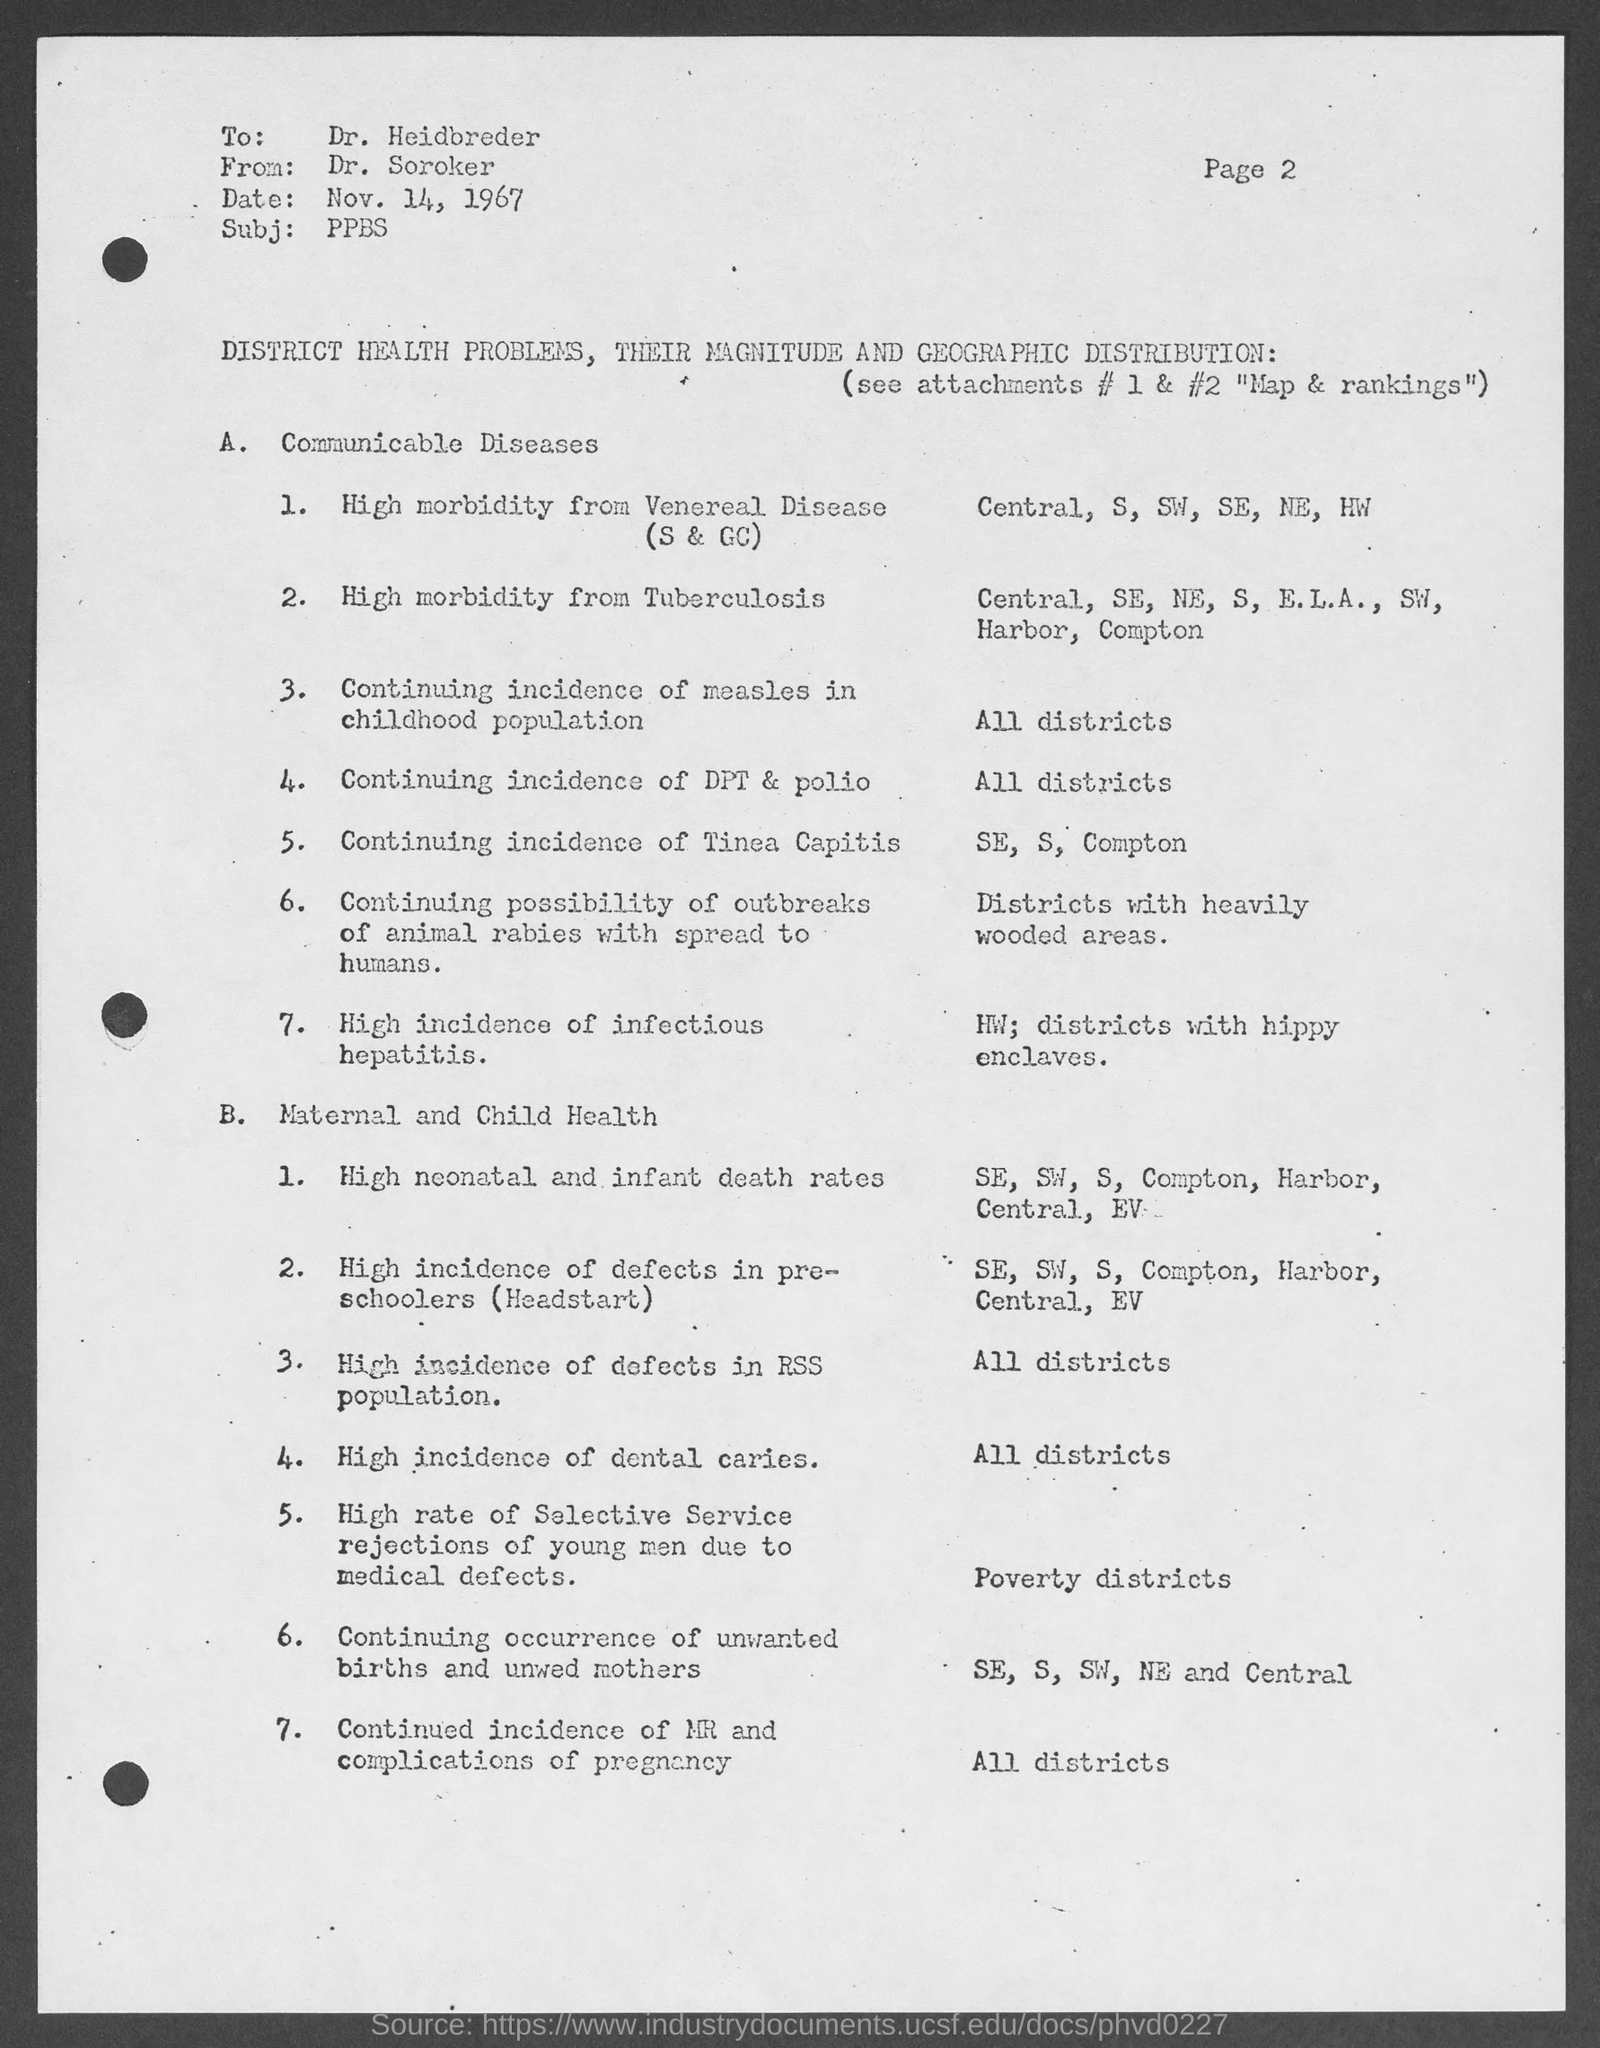Give some essential details in this illustration. The document mentions that the date is November 14, 1967. The receiver of this document is Dr. Heidbreder. The subject mentioned in the document is "PPBS..". The sender of this document is Dr. Soroker. What is the topic discussed in subheading A? The topic discussed in subheading A is communicable diseases. 